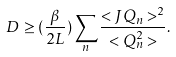Convert formula to latex. <formula><loc_0><loc_0><loc_500><loc_500>D \geq ( \frac { \beta } { 2 L } ) \sum _ { n } \frac { < J Q _ { n } > ^ { 2 } } { < Q _ { n } ^ { 2 } > } .</formula> 